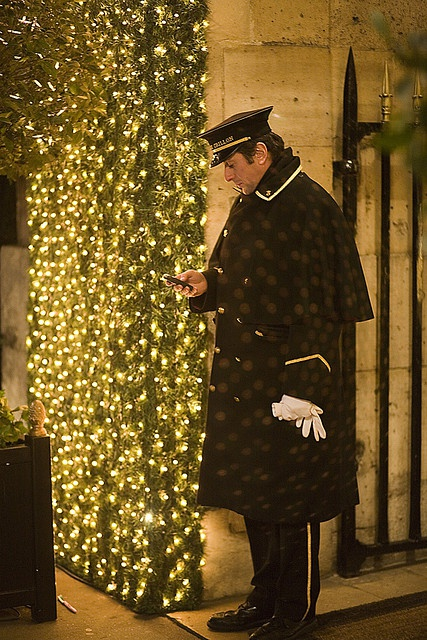Describe the objects in this image and their specific colors. I can see people in black, maroon, and brown tones and cell phone in black, maroon, and olive tones in this image. 